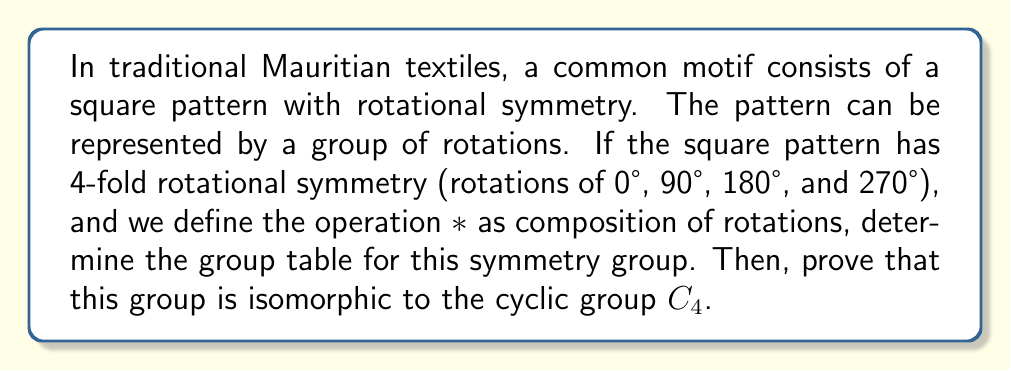Give your solution to this math problem. Let's approach this step-by-step:

1) First, let's define our group elements:
   $e$ : rotation by 0° (identity)
   $r$ : rotation by 90° clockwise
   $r^2$ : rotation by 180°
   $r^3$ : rotation by 270° clockwise (or 90° counterclockwise)

2) Now, let's construct the group table:

   $$\begin{array}{c|cccc}
   * & e & r & r^2 & r^3 \\
   \hline
   e & e & r & r^2 & r^3 \\
   r & r & r^2 & r^3 & e \\
   r^2 & r^2 & r^3 & e & r \\
   r^3 & r^3 & e & r & r^2
   \end{array}$$

3) To prove that this group is isomorphic to $C_4$, we need to show that there exists a bijective homomorphism from this group to $C_4$.

4) Let's define a mapping $\phi$ from our rotation group to $C_4 = \{0, 1, 2, 3\}$ under addition modulo 4:

   $\phi(e) = 0$
   $\phi(r) = 1$
   $\phi(r^2) = 2$
   $\phi(r^3) = 3$

5) To prove this is an isomorphism, we need to show it's bijective and preserves the operation:

   a) It's bijective because it's a one-to-one correspondence between the elements.

   b) To show it preserves the operation, we need to check that for any elements $a$ and $b$ in our rotation group:

      $\phi(a * b) = \phi(a) + \phi(b) \pmod{4}$

      For example:
      $\phi(r * r^2) = \phi(r^3) = 3$
      $\phi(r) + \phi(r^2) = 1 + 2 = 3 \pmod{4}$

6) You can verify this holds for all combinations in the group table.

Therefore, we have shown that our rotation group is isomorphic to $C_4$.
Answer: The group table for the 4-fold rotational symmetry group is:

$$\begin{array}{c|cccc}
* & e & r & r^2 & r^3 \\
\hline
e & e & r & r^2 & r^3 \\
r & r & r^2 & r^3 & e \\
r^2 & r^2 & r^3 & e & r \\
r^3 & r^3 & e & r & r^2
\end{array}$$

This group is isomorphic to the cyclic group $C_4$. 